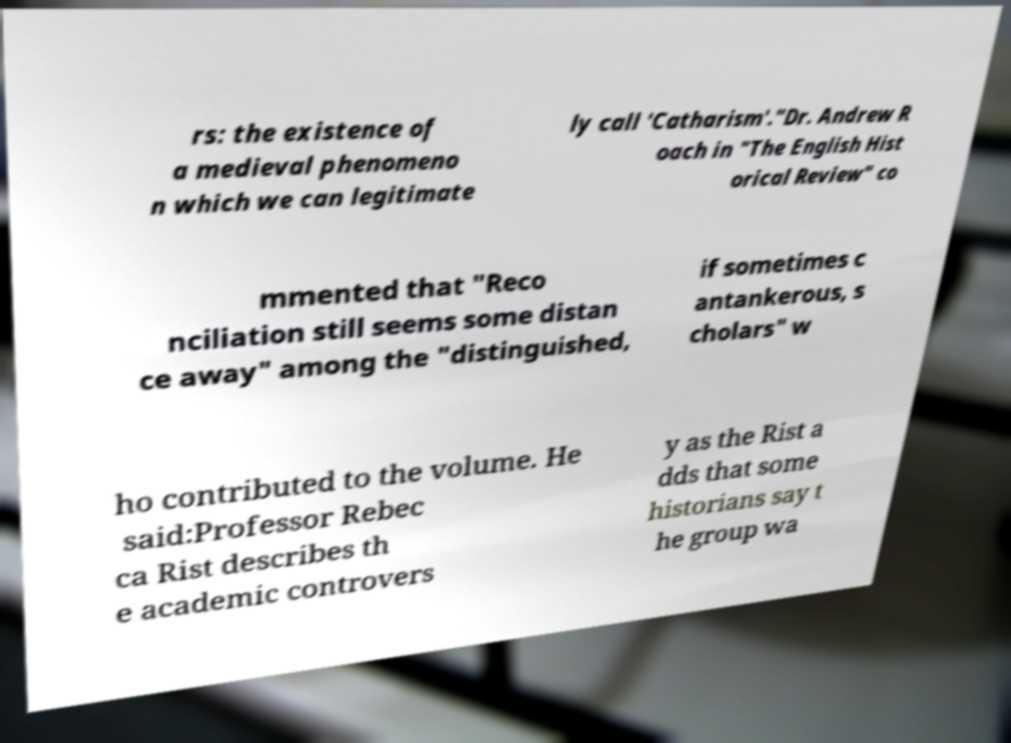Could you extract and type out the text from this image? rs: the existence of a medieval phenomeno n which we can legitimate ly call 'Catharism'."Dr. Andrew R oach in "The English Hist orical Review" co mmented that "Reco nciliation still seems some distan ce away" among the "distinguished, if sometimes c antankerous, s cholars" w ho contributed to the volume. He said:Professor Rebec ca Rist describes th e academic controvers y as the Rist a dds that some historians say t he group wa 